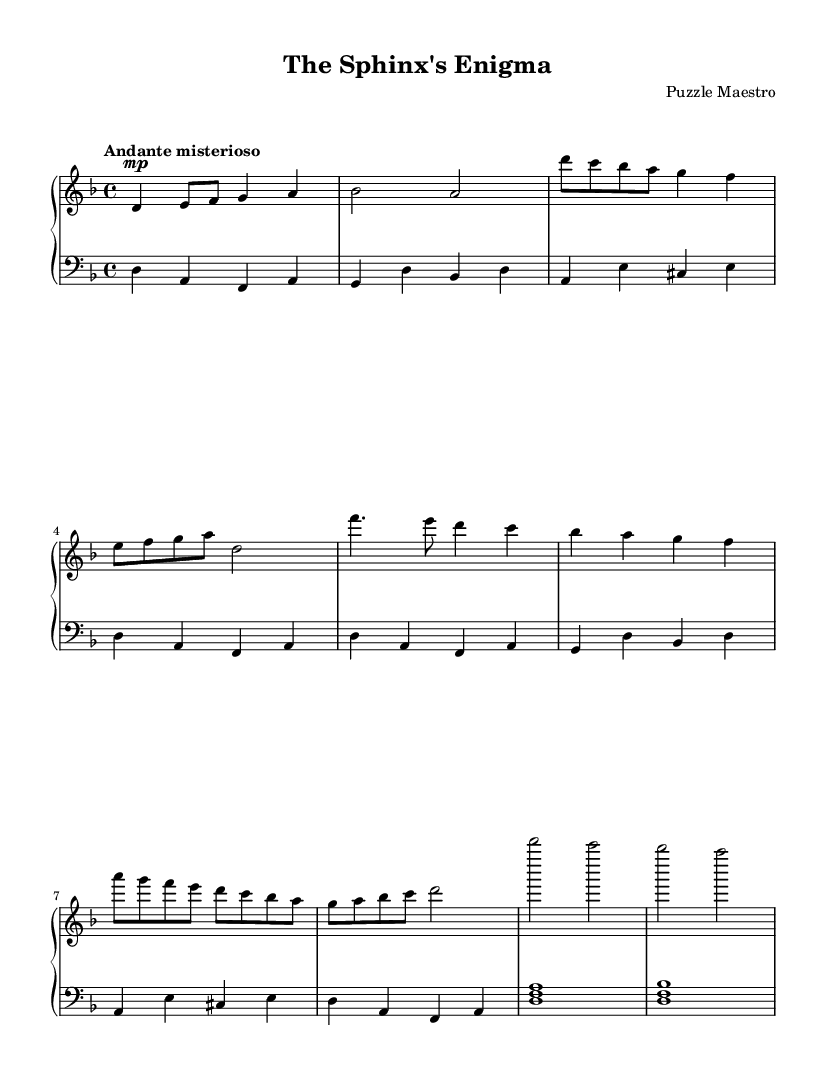What is the key signature of this music? The key signature of this piece is D minor, indicated by one flat (B flat) on the staff.
Answer: D minor What is the time signature of this music? The time signature shown in the sheet music is 4/4, meaning there are four beats per measure and the quarter note gets one beat.
Answer: 4/4 What is the tempo marking of this piece? The piece is marked as "Andante misterioso," indicating a moderate and mysterious pace.
Answer: Andante misterioso Which section contains Theme A? Theme A is found after the introduction in the right hand, starting with the notes D, C, B flat, A, and G.
Answer: After the introduction How many measures are in the coda section? The coda section, as indicated in the sheet music, has 2 measures, which show the final notes of the piece.
Answer: 2 What is the dynamic indication for the introduction? The introduction starts with a dynamic indication of "mp," which stands for mezzo-piano, meaning moderately soft.
Answer: mp What is the root note of the left-hand chords in the coda? The left-hand chords in the coda are built around the root note D, using D, F, and A for the first chord and D, F, and B flat for the second.
Answer: D 